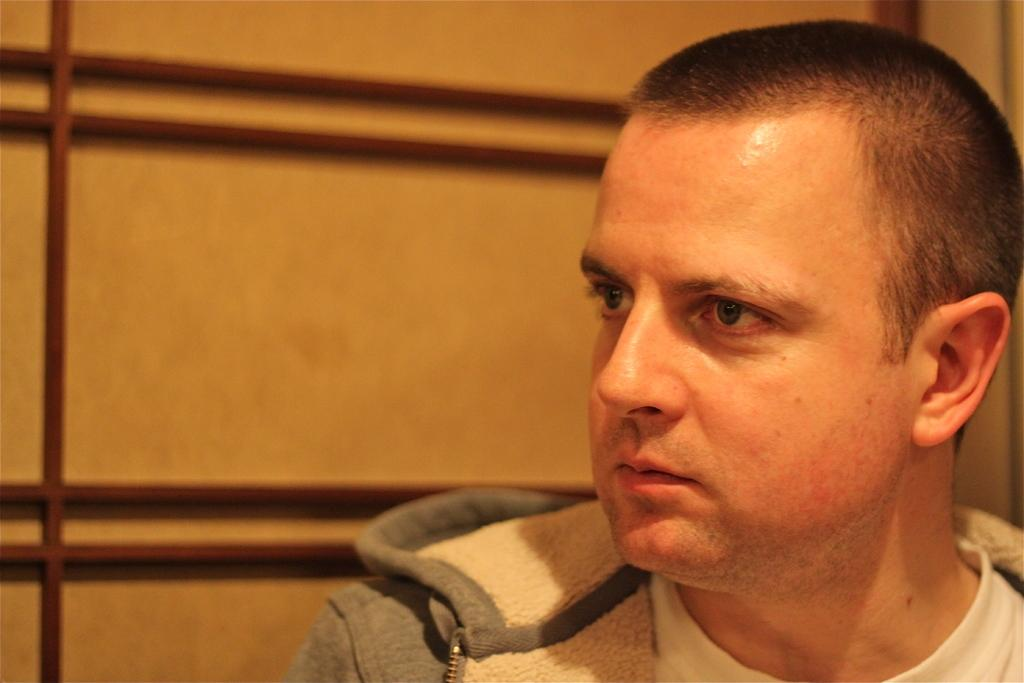Who is present in the image? There is a man in the image. What can be seen in the background of the image? There is a wall in the background of the image. What is the texture of the man's shirt in the image? The texture of the man's shirt cannot be determined from the image, as the image does not provide enough detail to discern the texture. 